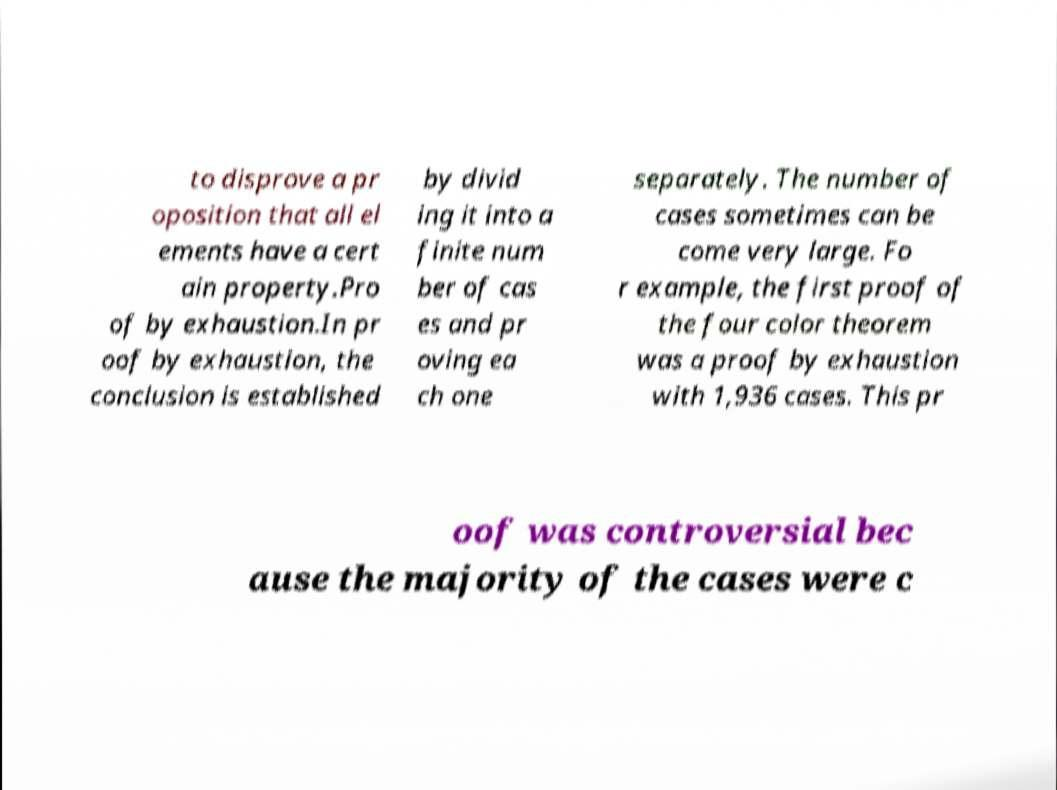Can you accurately transcribe the text from the provided image for me? to disprove a pr oposition that all el ements have a cert ain property.Pro of by exhaustion.In pr oof by exhaustion, the conclusion is established by divid ing it into a finite num ber of cas es and pr oving ea ch one separately. The number of cases sometimes can be come very large. Fo r example, the first proof of the four color theorem was a proof by exhaustion with 1,936 cases. This pr oof was controversial bec ause the majority of the cases were c 